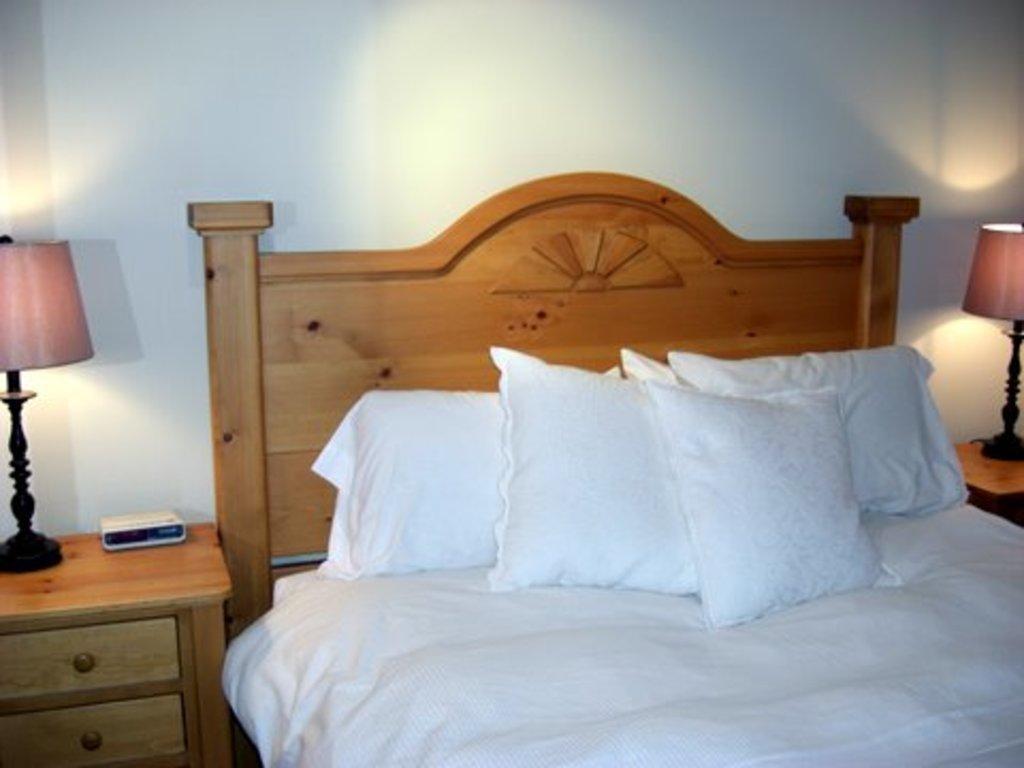Could you give a brief overview of what you see in this image? This picture shows a bed and we see few pillows and couple of lamps on the tables and we see draws to the table and we see a white color wall and a box on the table. 